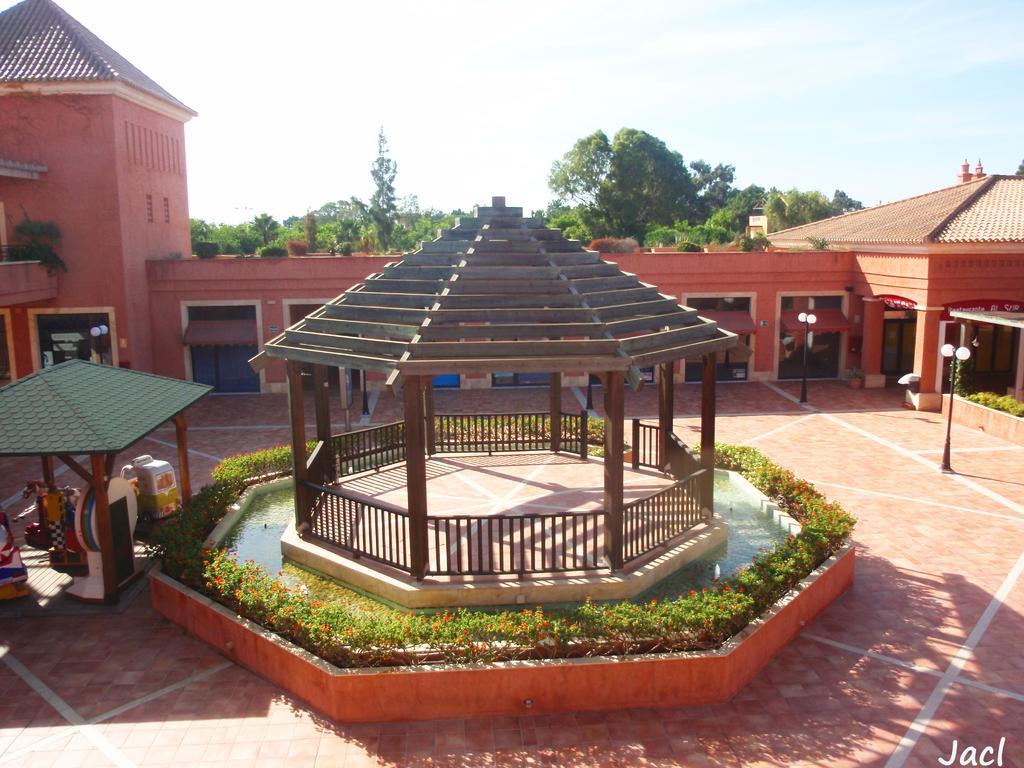Describe this image in one or two sentences. This looks like a building. I think these are the light poles. I can see the bushes with the flowers. These are the objects, which are under the shed. These are the trees and plants. Here is the sky. This is a kind of shelter with a spire on it. I can see the watermark on the image. 